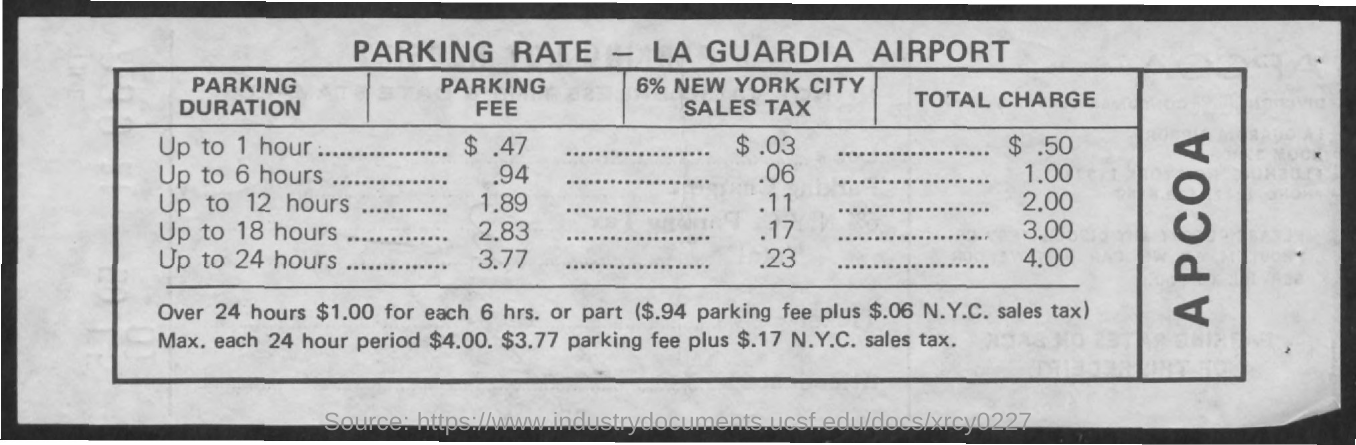Outline some significant characteristics in this image. The total charge for parking for up to 24 hours is $4.00. The parking fee for a period of 24 hours is approximately 3.77. The name of the airport is LaGuardia Airport. The total charge for parking for one hour is $0.50. The parking fee for a maximum of 6 hours is approximately $0.94. 